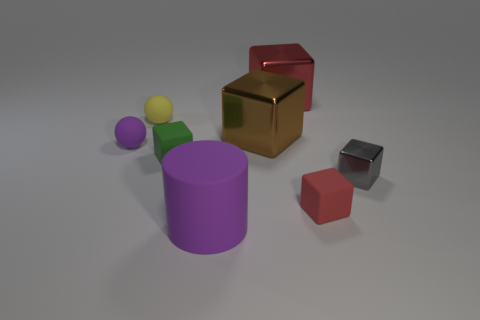There is a thing that is the same color as the rubber cylinder; what is its size?
Your response must be concise. Small. Are there any small matte things to the left of the large purple cylinder?
Make the answer very short. Yes. There is a big purple thing; what shape is it?
Provide a succinct answer. Cylinder. There is a rubber object that is behind the purple thing behind the rubber block that is on the left side of the tiny red thing; what shape is it?
Offer a very short reply. Sphere. What number of other things are the same shape as the green object?
Offer a terse response. 4. What is the red block that is to the left of the rubber block on the right side of the large rubber cylinder made of?
Give a very brief answer. Metal. Are there any other things that are the same size as the gray object?
Keep it short and to the point. Yes. Are the green block and the red object that is in front of the small green block made of the same material?
Your answer should be very brief. Yes. What is the material of the big object that is on the right side of the large purple object and in front of the small yellow thing?
Provide a short and direct response. Metal. The tiny rubber object that is to the right of the large object in front of the tiny green rubber thing is what color?
Your answer should be very brief. Red. 